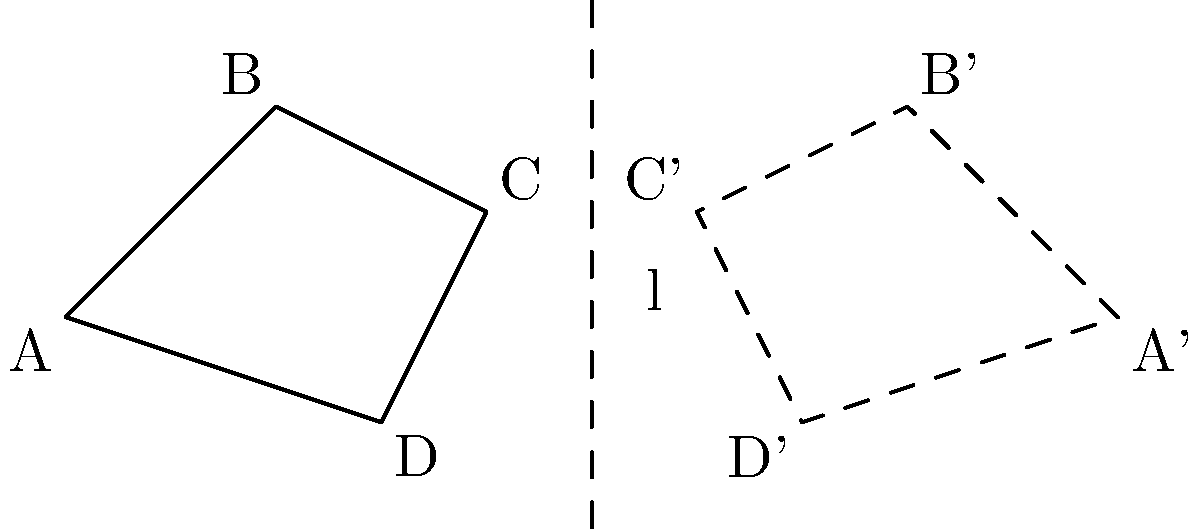In the diagram, quadrilateral $ABCD$ is reflected across line $l$ to form quadrilateral $A'B'C'D'$. If the coordinates of point $A$ are $(-2,1)$ and the equation of line $l$ is $x=3$, what are the coordinates of point $A'$? To find the coordinates of point $A'$, we need to reflect point $A$ across line $l$. Here's how we can do it step-by-step:

1) The equation of line $l$ is $x=3$. This means it's a vertical line passing through $x=3$.

2) To reflect a point across a vertical line, we keep the y-coordinate the same and adjust the x-coordinate.

3) The x-coordinate of $A$ is $-2$, and the line is at $x=3$. The distance between these is $3 - (-2) = 5$.

4) When reflecting, this distance is maintained on the other side of the line. So, the x-coordinate of $A'$ will be $3 + 5 = 8$.

5) The y-coordinate remains unchanged at $1$.

Therefore, the coordinates of $A'$ are $(8,1)$.
Answer: $(8,1)$ 